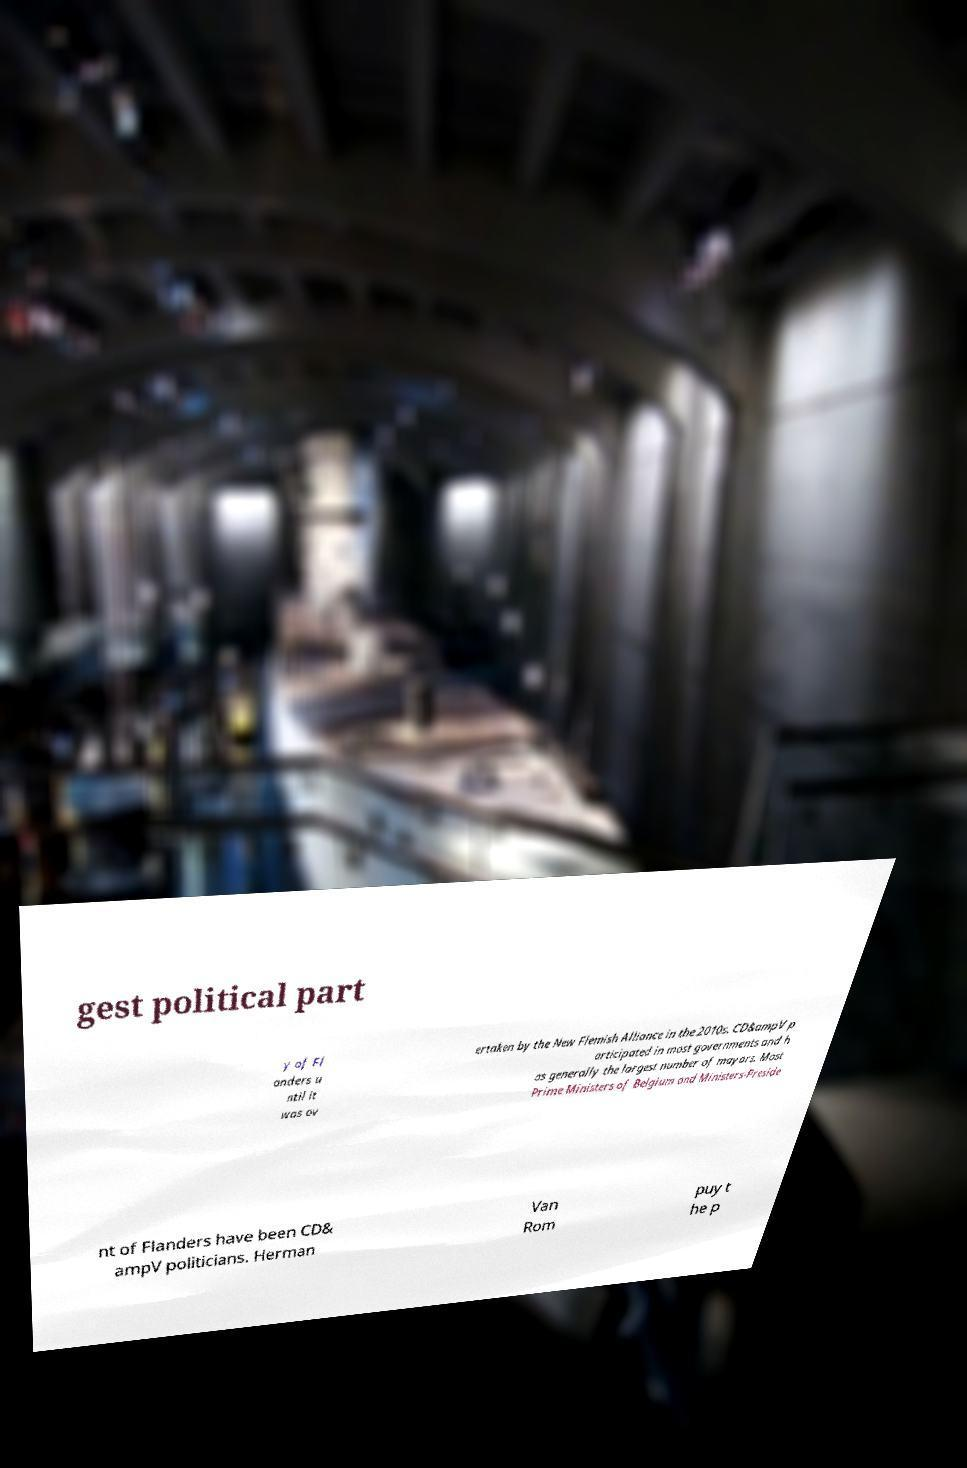Please identify and transcribe the text found in this image. gest political part y of Fl anders u ntil it was ov ertaken by the New Flemish Alliance in the 2010s. CD&ampV p articipated in most governments and h as generally the largest number of mayors. Most Prime Ministers of Belgium and Ministers-Preside nt of Flanders have been CD& ampV politicians. Herman Van Rom puy t he p 